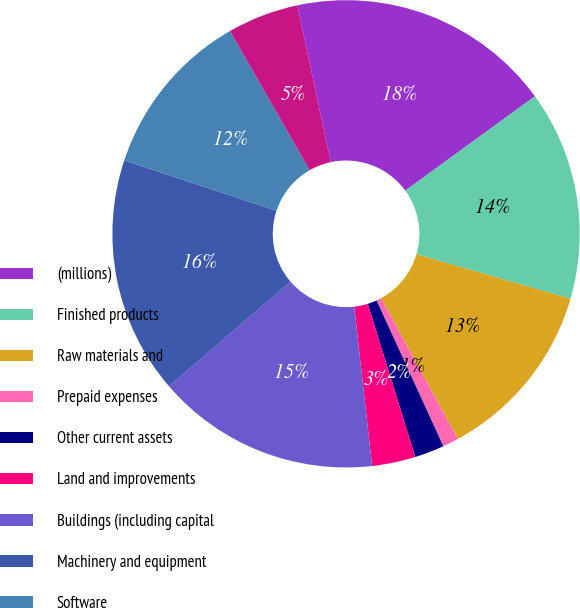Convert chart. <chart><loc_0><loc_0><loc_500><loc_500><pie_chart><fcel>(millions)<fcel>Finished products<fcel>Raw materials and<fcel>Prepaid expenses<fcel>Other current assets<fcel>Land and improvements<fcel>Buildings (including capital<fcel>Machinery and equipment<fcel>Software<fcel>Construction-in-progress<nl><fcel>18.33%<fcel>14.5%<fcel>12.58%<fcel>1.1%<fcel>2.05%<fcel>3.01%<fcel>15.46%<fcel>16.41%<fcel>11.63%<fcel>4.93%<nl></chart> 